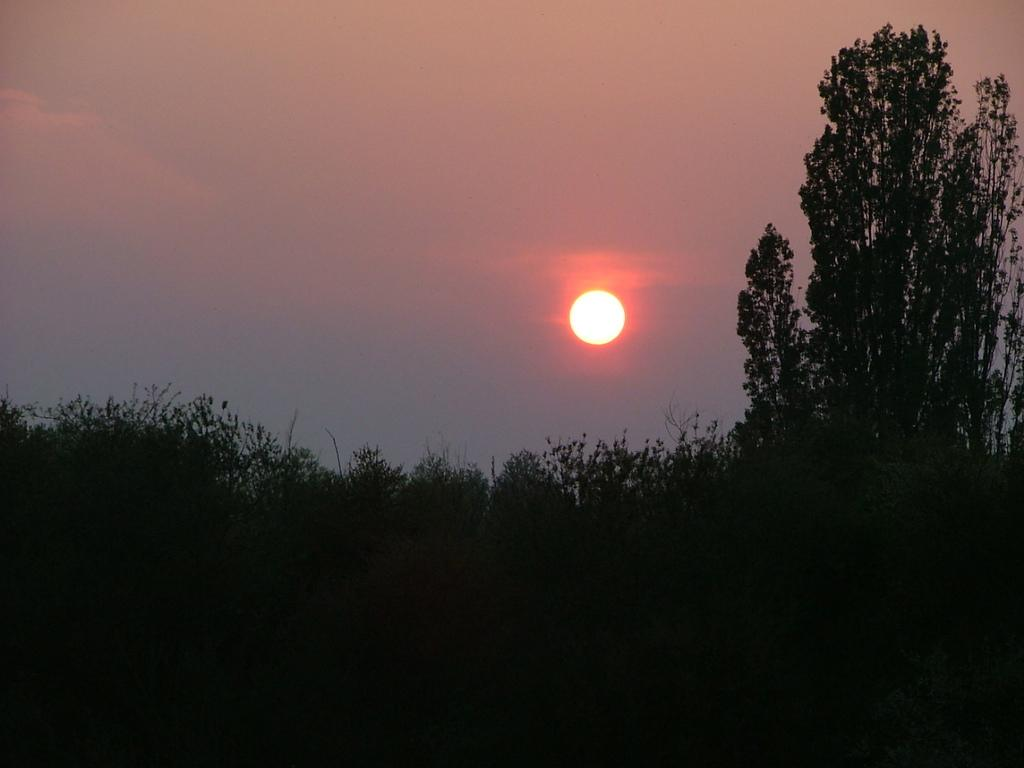What type of vegetation is visible in the image? There are trees in the image. What is visible in the background of the image? The sky is visible in the background of the image. Can the sun be seen in the image? Yes, the sun is observable in the sky. How many roses are visible in the image? There are no roses present in the image; it features trees and the sky. Is there any indication of an attack happening in the image? There is no indication of an attack in the image; it is a peaceful scene with trees and the sky. 